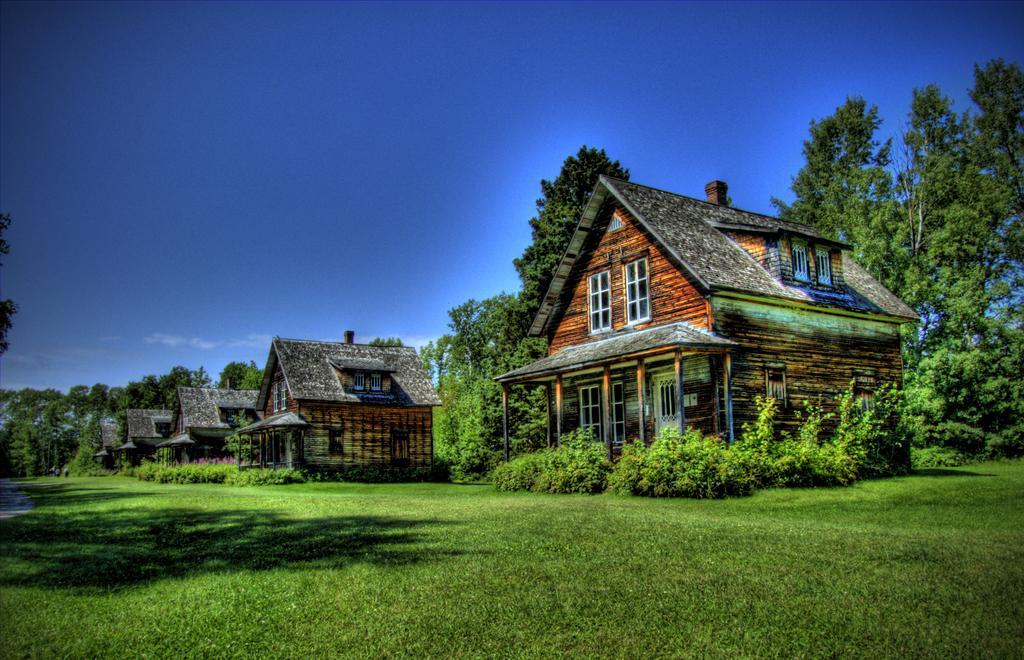Please provide a concise description of this image. There are cottages on the ground, on which, there is grass, there are plants and trees. In the background, there is blue sky. 